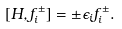<formula> <loc_0><loc_0><loc_500><loc_500>[ H , f ^ { \pm } _ { i } ] = \pm \epsilon _ { i } f _ { i } ^ { \pm } .</formula> 